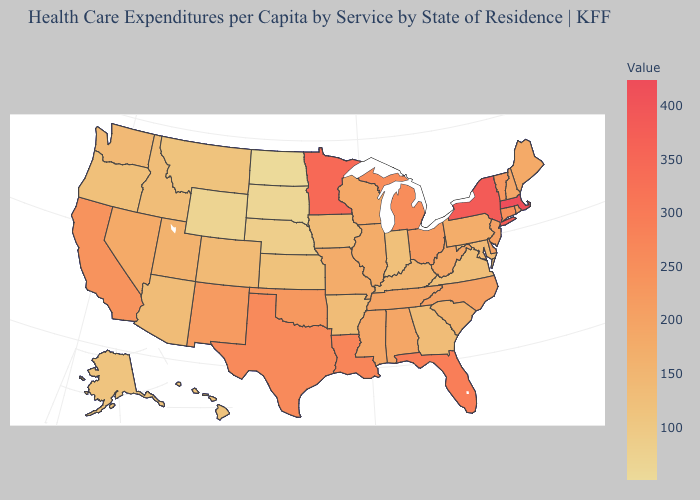Which states have the lowest value in the MidWest?
Give a very brief answer. North Dakota. Which states have the lowest value in the USA?
Be succinct. North Dakota. Is the legend a continuous bar?
Write a very short answer. Yes. Does Idaho have a lower value than Delaware?
Concise answer only. Yes. Is the legend a continuous bar?
Be succinct. Yes. Does North Dakota have the lowest value in the USA?
Give a very brief answer. Yes. Does Delaware have a higher value than Massachusetts?
Be succinct. No. Does Minnesota have the highest value in the MidWest?
Be succinct. Yes. Does Oklahoma have a lower value than New York?
Be succinct. Yes. 